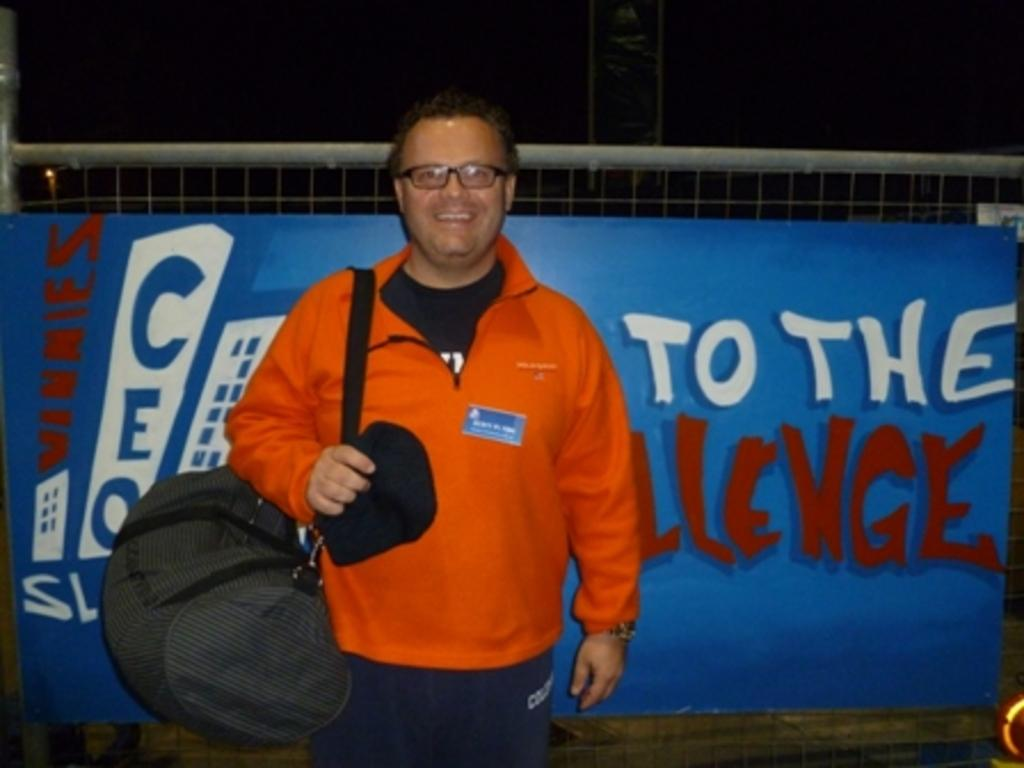What is the main subject in the image? There is a person standing in the middle of the image. What is the person holding in the image? The person is holding a bag. What can be seen in the background of the image? There is a blue color poster in the background. How is the poster positioned in the image? The poster is attached to a fencing. What type of lumber is being used to build the land in the image? There is no land or lumber present in the image; it features a person standing with a bag and a blue color poster in the background. 